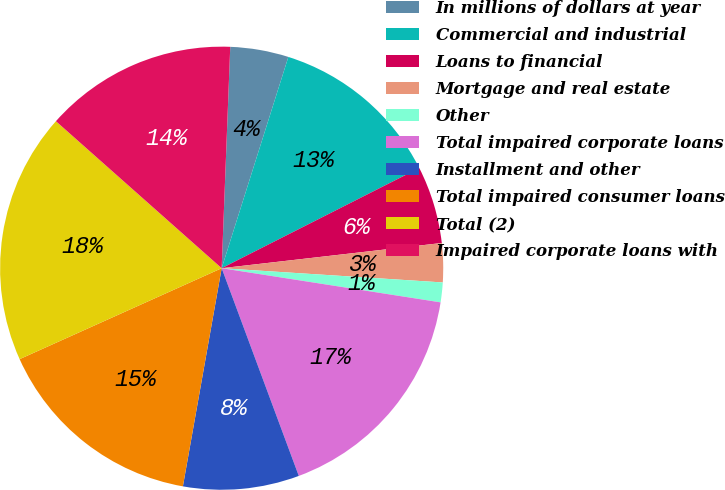Convert chart to OTSL. <chart><loc_0><loc_0><loc_500><loc_500><pie_chart><fcel>In millions of dollars at year<fcel>Commercial and industrial<fcel>Loans to financial<fcel>Mortgage and real estate<fcel>Other<fcel>Total impaired corporate loans<fcel>Installment and other<fcel>Total impaired consumer loans<fcel>Total (2)<fcel>Impaired corporate loans with<nl><fcel>4.25%<fcel>12.67%<fcel>5.65%<fcel>2.84%<fcel>1.44%<fcel>16.88%<fcel>8.46%<fcel>15.47%<fcel>18.28%<fcel>14.07%<nl></chart> 